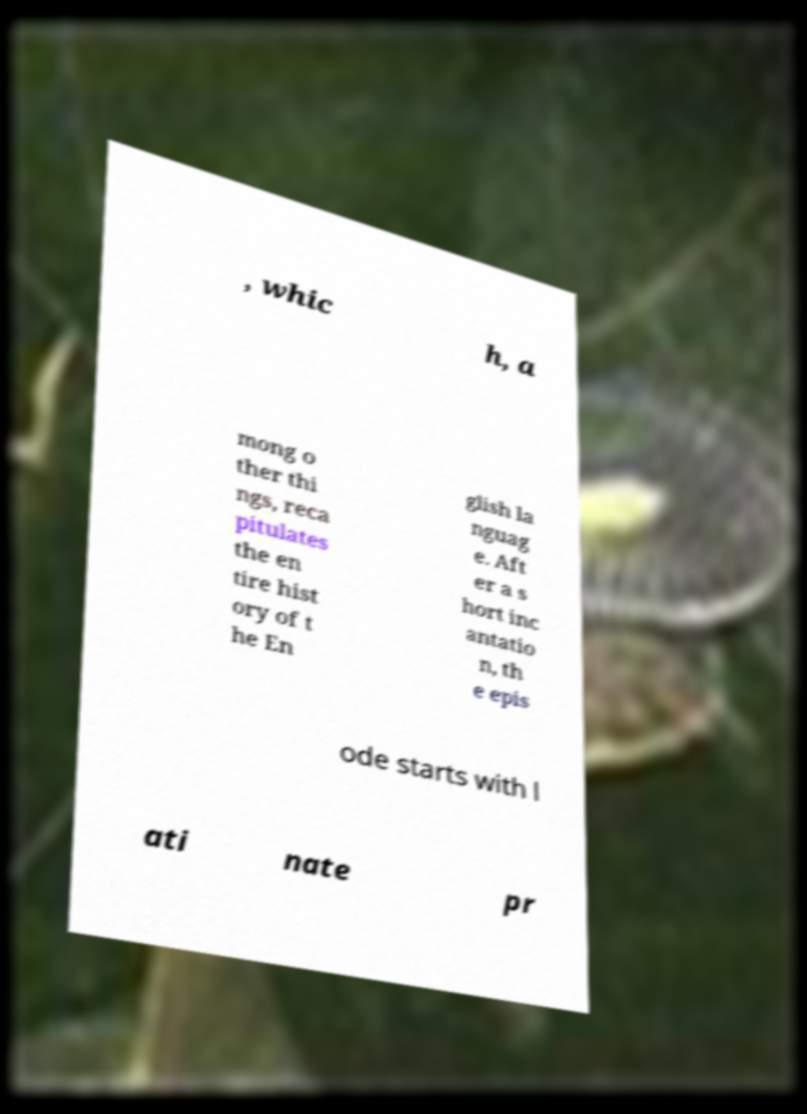Can you read and provide the text displayed in the image?This photo seems to have some interesting text. Can you extract and type it out for me? , whic h, a mong o ther thi ngs, reca pitulates the en tire hist ory of t he En glish la nguag e. Aft er a s hort inc antatio n, th e epis ode starts with l ati nate pr 